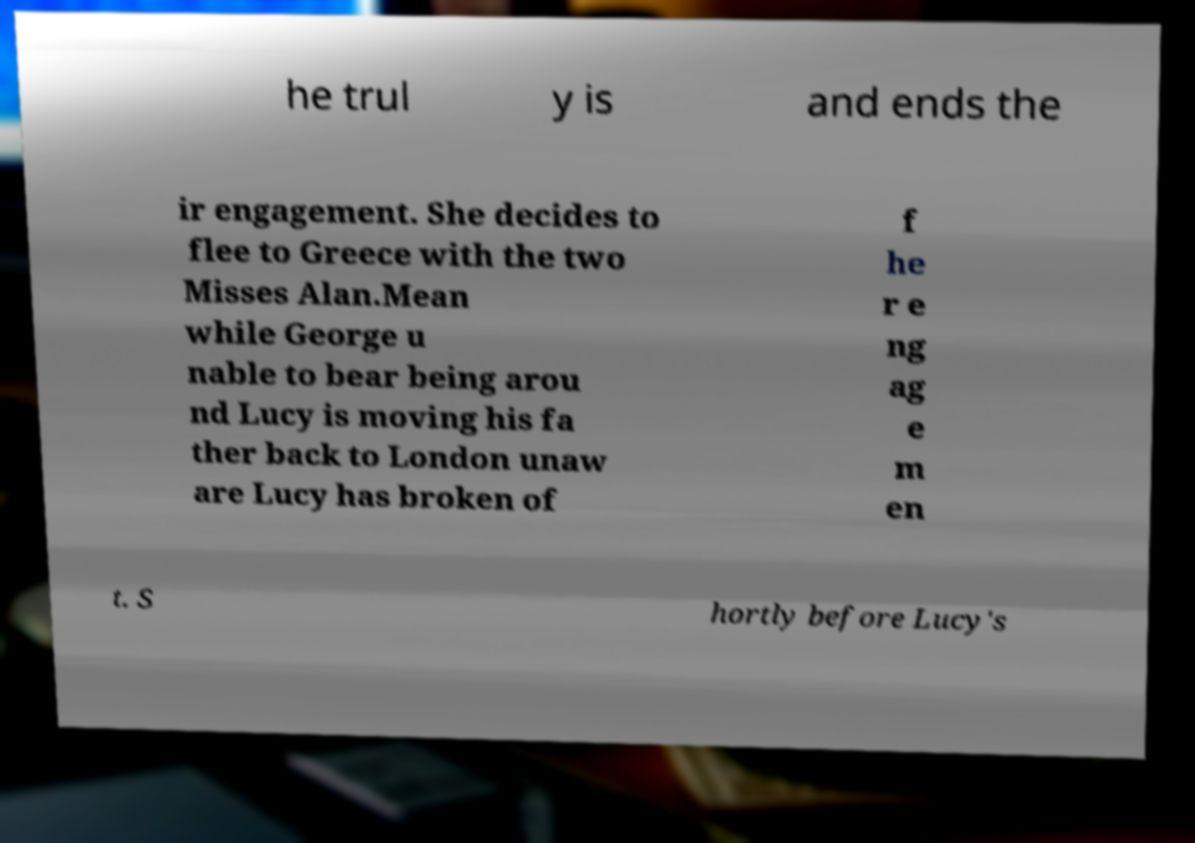Can you accurately transcribe the text from the provided image for me? he trul y is and ends the ir engagement. She decides to flee to Greece with the two Misses Alan.Mean while George u nable to bear being arou nd Lucy is moving his fa ther back to London unaw are Lucy has broken of f he r e ng ag e m en t. S hortly before Lucy's 